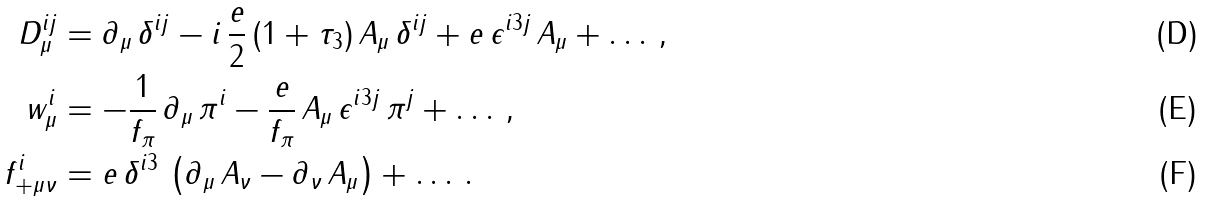<formula> <loc_0><loc_0><loc_500><loc_500>D _ { \mu } ^ { i j } & = \partial _ { \mu } \, \delta ^ { i j } - i \, \frac { e } { 2 } \, ( 1 + \tau _ { 3 } ) \, A _ { \mu } \, \delta ^ { i j } + e \, \epsilon ^ { i 3 j } \, A _ { \mu } + \dots \, , \\ w _ { \mu } ^ { i } & = - \frac { 1 } { f _ { \pi } } \, \partial _ { \mu } \, \pi ^ { i } - \frac { e } { f _ { \pi } } \, A _ { \mu } \, \epsilon ^ { i 3 j } \, \pi ^ { j } + \dots \, , \\ f ^ { i } _ { + \mu \nu } & = e \, \delta ^ { i 3 } \, \left ( \partial _ { \mu } \, A _ { \nu } - \partial _ { \nu } \, A _ { \mu } \right ) + \dots \, .</formula> 